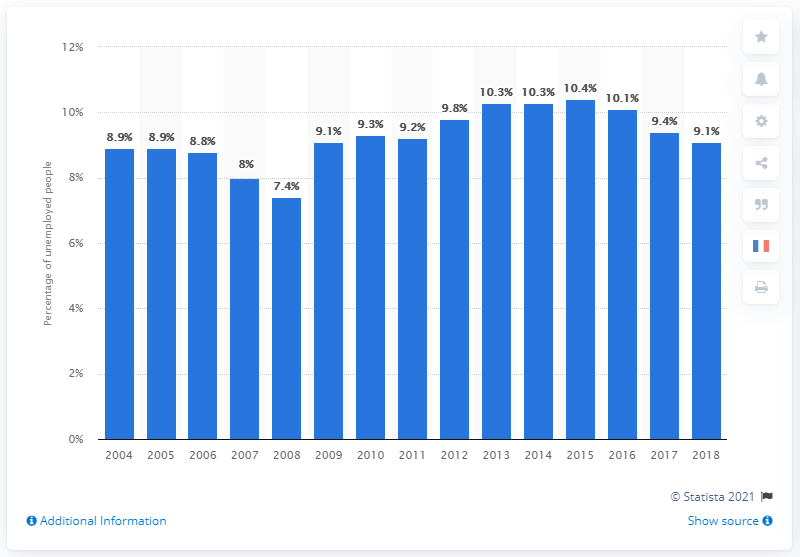Outline some significant characteristics in this image. The unemployment rate in France was 10.3% in 2010. 